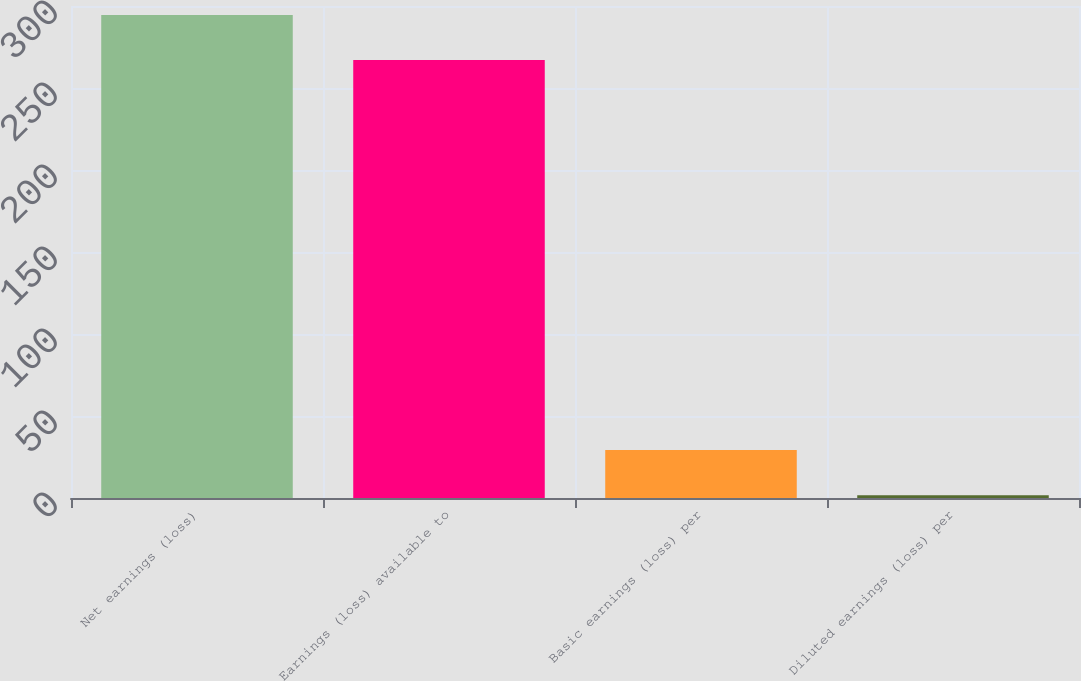<chart> <loc_0><loc_0><loc_500><loc_500><bar_chart><fcel>Net earnings (loss)<fcel>Earnings (loss) available to<fcel>Basic earnings (loss) per<fcel>Diluted earnings (loss) per<nl><fcel>294.53<fcel>267<fcel>29.2<fcel>1.67<nl></chart> 